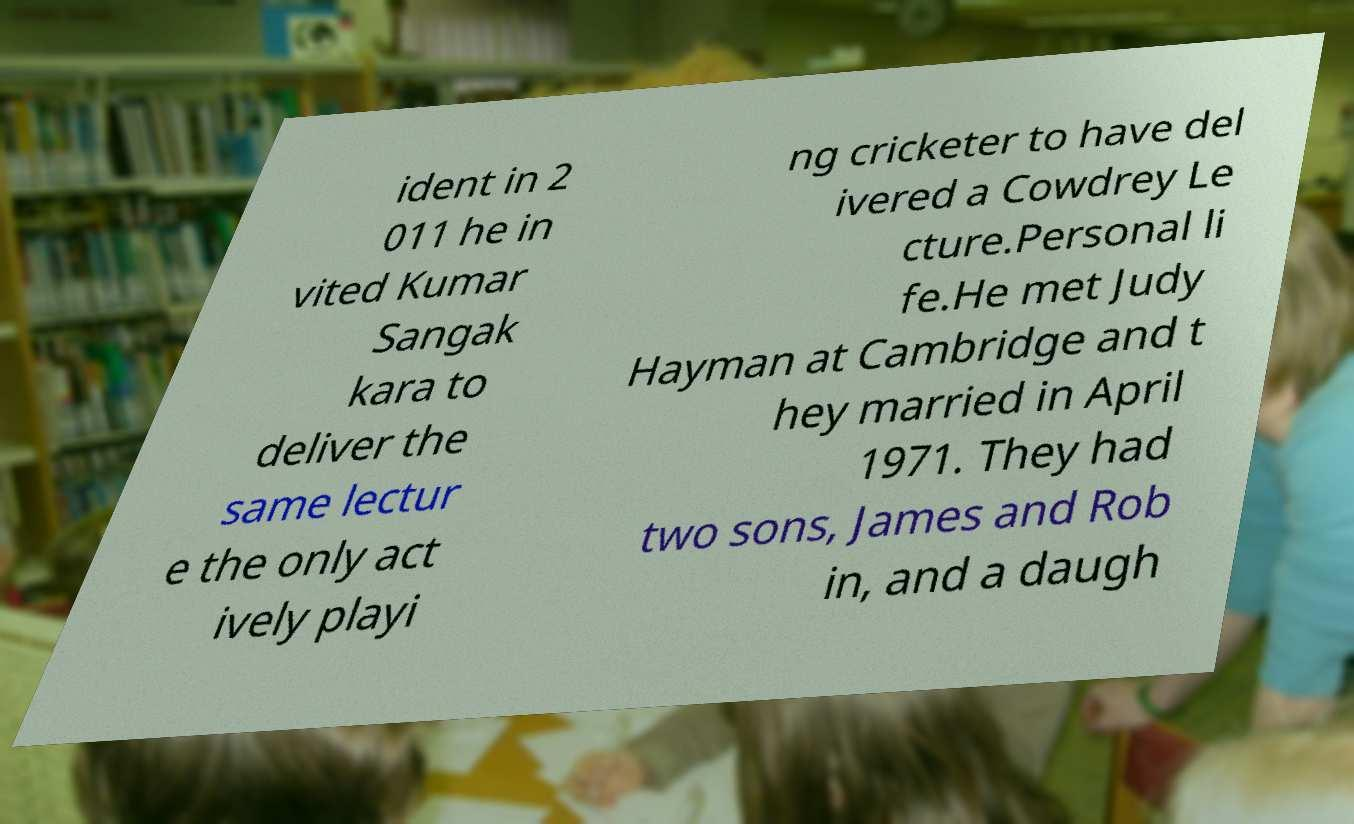For documentation purposes, I need the text within this image transcribed. Could you provide that? ident in 2 011 he in vited Kumar Sangak kara to deliver the same lectur e the only act ively playi ng cricketer to have del ivered a Cowdrey Le cture.Personal li fe.He met Judy Hayman at Cambridge and t hey married in April 1971. They had two sons, James and Rob in, and a daugh 